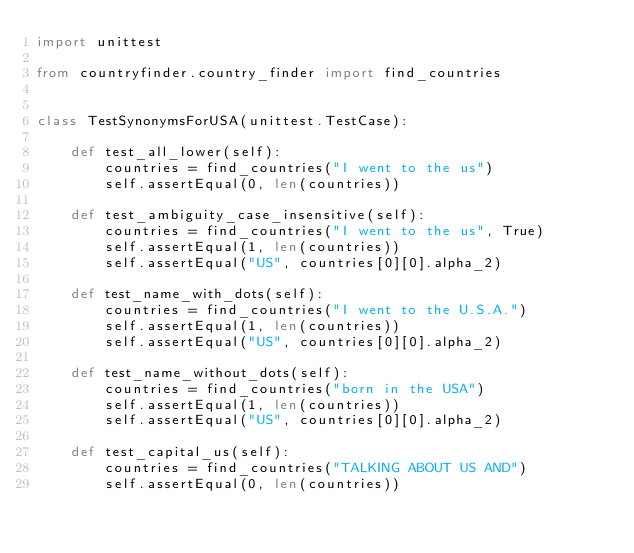Convert code to text. <code><loc_0><loc_0><loc_500><loc_500><_Python_>import unittest

from countryfinder.country_finder import find_countries


class TestSynonymsForUSA(unittest.TestCase):

    def test_all_lower(self):
        countries = find_countries("I went to the us")
        self.assertEqual(0, len(countries))

    def test_ambiguity_case_insensitive(self):
        countries = find_countries("I went to the us", True)
        self.assertEqual(1, len(countries))
        self.assertEqual("US", countries[0][0].alpha_2)

    def test_name_with_dots(self):
        countries = find_countries("I went to the U.S.A.")
        self.assertEqual(1, len(countries))
        self.assertEqual("US", countries[0][0].alpha_2)

    def test_name_without_dots(self):
        countries = find_countries("born in the USA")
        self.assertEqual(1, len(countries))
        self.assertEqual("US", countries[0][0].alpha_2)

    def test_capital_us(self):
        countries = find_countries("TALKING ABOUT US AND")
        self.assertEqual(0, len(countries))

</code> 